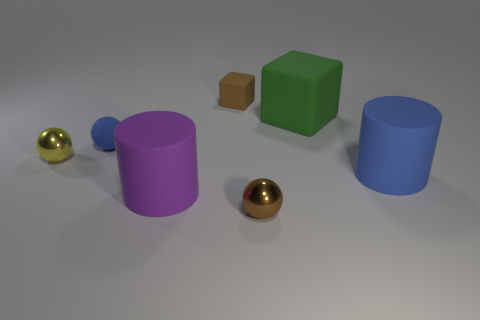Subtract all brown shiny spheres. How many spheres are left? 2 Add 1 large blue objects. How many objects exist? 8 Subtract all brown balls. How many balls are left? 2 Subtract all cubes. How many objects are left? 5 Subtract 1 blocks. How many blocks are left? 1 Subtract all large cylinders. Subtract all large green cubes. How many objects are left? 4 Add 7 brown things. How many brown things are left? 9 Add 1 small green metallic cylinders. How many small green metallic cylinders exist? 1 Subtract 0 red cubes. How many objects are left? 7 Subtract all yellow cubes. Subtract all red cylinders. How many cubes are left? 2 